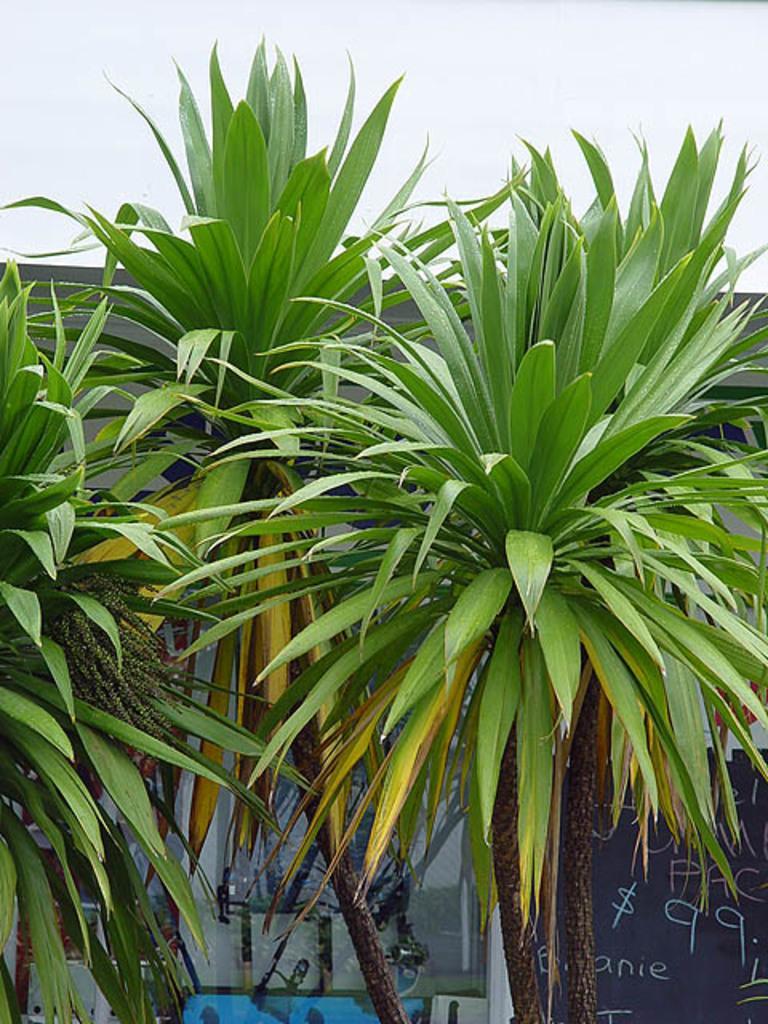Please provide a concise description of this image. In this image, we can see some trees and a board with some text. We can also see some glass and a few objects. We can also see a blue colored object and the sky. 